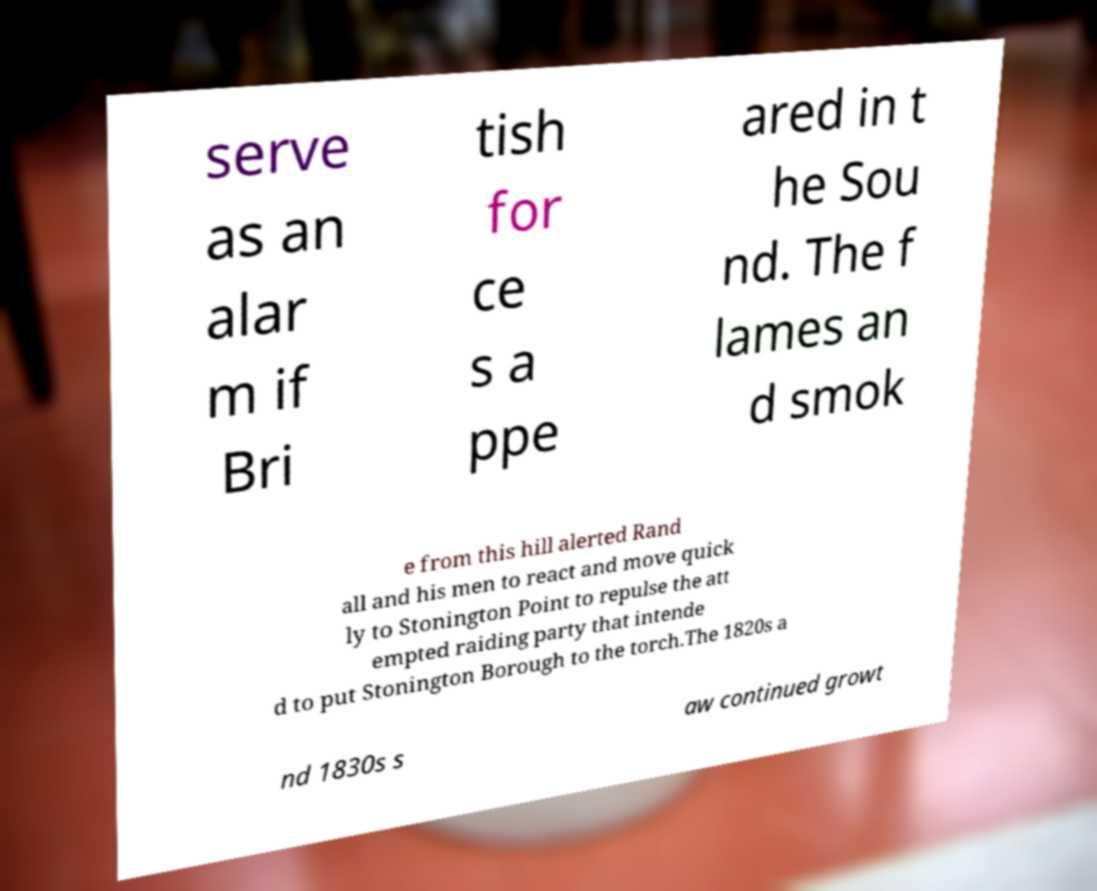Can you accurately transcribe the text from the provided image for me? serve as an alar m if Bri tish for ce s a ppe ared in t he Sou nd. The f lames an d smok e from this hill alerted Rand all and his men to react and move quick ly to Stonington Point to repulse the att empted raiding party that intende d to put Stonington Borough to the torch.The 1820s a nd 1830s s aw continued growt 